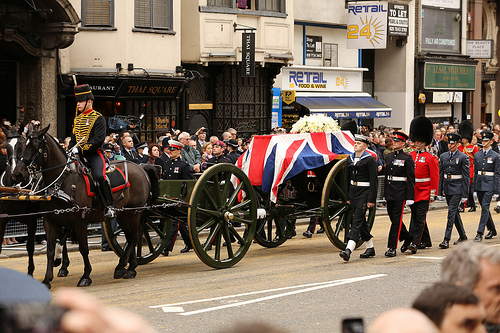What is the brown animal pulling? The brown animal, which is a horse, is pulling a wagon. 